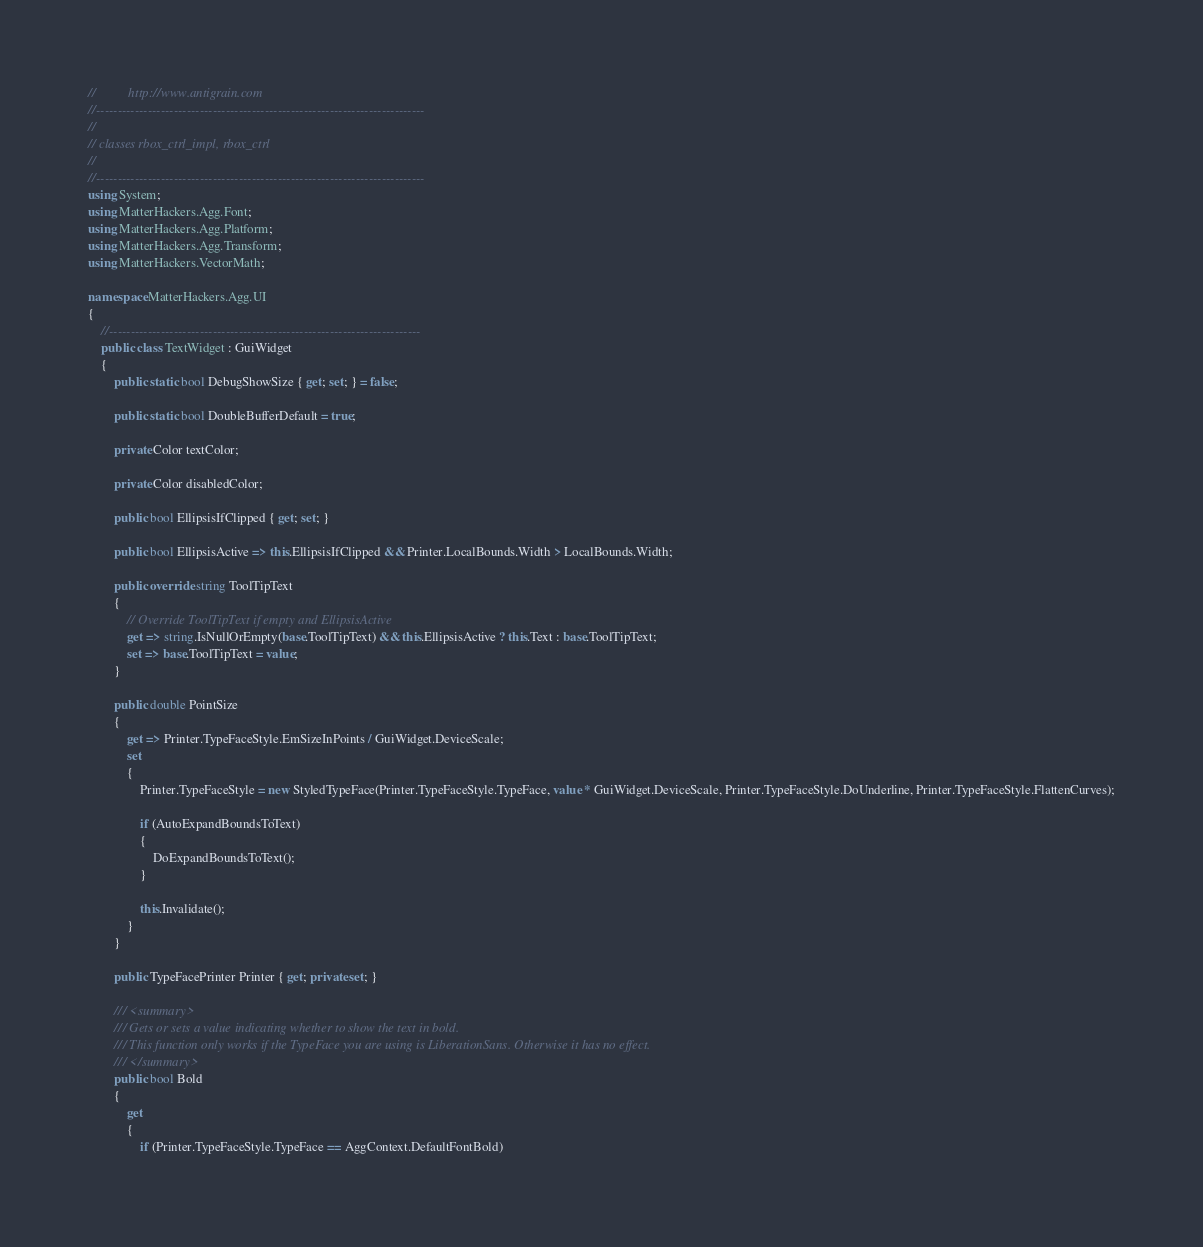Convert code to text. <code><loc_0><loc_0><loc_500><loc_500><_C#_>//          http://www.antigrain.com
//----------------------------------------------------------------------------
//
// classes rbox_ctrl_impl, rbox_ctrl
//
//----------------------------------------------------------------------------
using System;
using MatterHackers.Agg.Font;
using MatterHackers.Agg.Platform;
using MatterHackers.Agg.Transform;
using MatterHackers.VectorMath;

namespace MatterHackers.Agg.UI
{
	//------------------------------------------------------------------------
	public class TextWidget : GuiWidget
	{
		public static bool DebugShowSize { get; set; } = false;

		public static bool DoubleBufferDefault = true;

		private Color textColor;

		private Color disabledColor;

		public bool EllipsisIfClipped { get; set; }

		public bool EllipsisActive => this.EllipsisIfClipped && Printer.LocalBounds.Width > LocalBounds.Width;

		public override string ToolTipText
		{
			// Override ToolTipText if empty and EllipsisActive
			get => string.IsNullOrEmpty(base.ToolTipText) && this.EllipsisActive ? this.Text : base.ToolTipText;
			set => base.ToolTipText = value;
		}

		public double PointSize
		{
			get => Printer.TypeFaceStyle.EmSizeInPoints / GuiWidget.DeviceScale;
			set
			{
				Printer.TypeFaceStyle = new StyledTypeFace(Printer.TypeFaceStyle.TypeFace, value * GuiWidget.DeviceScale, Printer.TypeFaceStyle.DoUnderline, Printer.TypeFaceStyle.FlattenCurves);

				if (AutoExpandBoundsToText)
				{
					DoExpandBoundsToText();
				}

				this.Invalidate();
			}
		}

		public TypeFacePrinter Printer { get; private set; }

		/// <summary>
		/// Gets or sets a value indicating whether to show the text in bold.
		/// This function only works if the TypeFace you are using is LiberationSans. Otherwise it has no effect.
		/// </summary>
		public bool Bold
		{
			get
			{
				if (Printer.TypeFaceStyle.TypeFace == AggContext.DefaultFontBold)</code> 